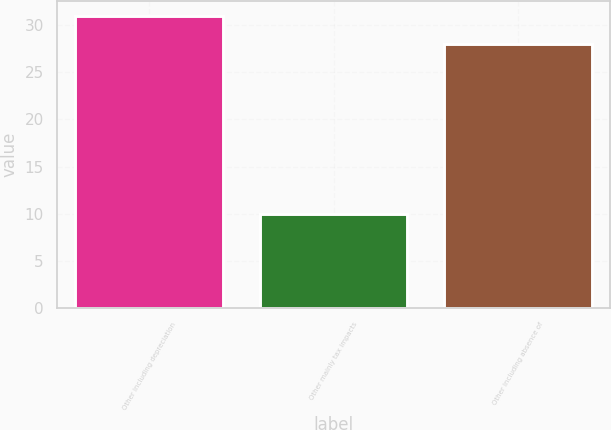Convert chart to OTSL. <chart><loc_0><loc_0><loc_500><loc_500><bar_chart><fcel>Other including depreciation<fcel>Other mainly tax impacts<fcel>Other including absence of<nl><fcel>31<fcel>10<fcel>28<nl></chart> 